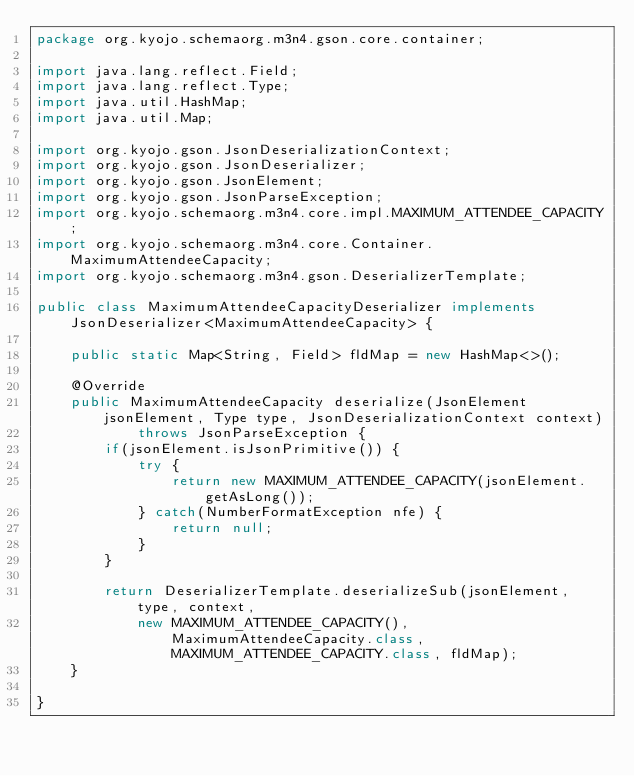<code> <loc_0><loc_0><loc_500><loc_500><_Java_>package org.kyojo.schemaorg.m3n4.gson.core.container;

import java.lang.reflect.Field;
import java.lang.reflect.Type;
import java.util.HashMap;
import java.util.Map;

import org.kyojo.gson.JsonDeserializationContext;
import org.kyojo.gson.JsonDeserializer;
import org.kyojo.gson.JsonElement;
import org.kyojo.gson.JsonParseException;
import org.kyojo.schemaorg.m3n4.core.impl.MAXIMUM_ATTENDEE_CAPACITY;
import org.kyojo.schemaorg.m3n4.core.Container.MaximumAttendeeCapacity;
import org.kyojo.schemaorg.m3n4.gson.DeserializerTemplate;

public class MaximumAttendeeCapacityDeserializer implements JsonDeserializer<MaximumAttendeeCapacity> {

	public static Map<String, Field> fldMap = new HashMap<>();

	@Override
	public MaximumAttendeeCapacity deserialize(JsonElement jsonElement, Type type, JsonDeserializationContext context)
			throws JsonParseException {
		if(jsonElement.isJsonPrimitive()) {
			try {
				return new MAXIMUM_ATTENDEE_CAPACITY(jsonElement.getAsLong());
			} catch(NumberFormatException nfe) {
				return null;
			}
		}

		return DeserializerTemplate.deserializeSub(jsonElement, type, context,
			new MAXIMUM_ATTENDEE_CAPACITY(), MaximumAttendeeCapacity.class, MAXIMUM_ATTENDEE_CAPACITY.class, fldMap);
	}

}
</code> 